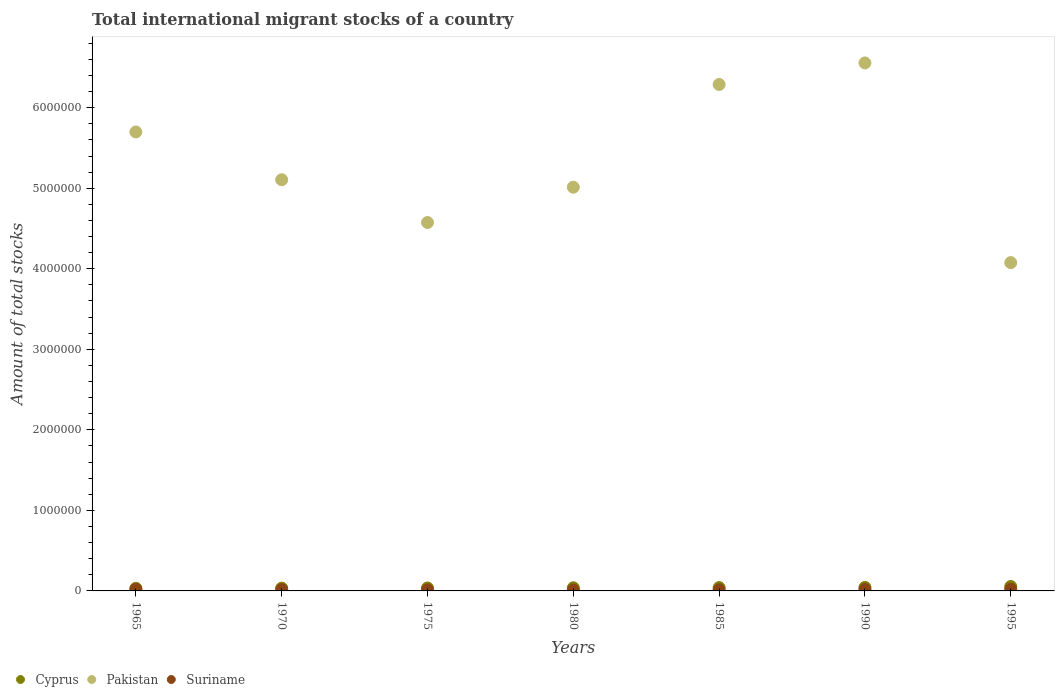How many different coloured dotlines are there?
Your answer should be compact. 3. Is the number of dotlines equal to the number of legend labels?
Your answer should be very brief. Yes. What is the amount of total stocks in in Pakistan in 1980?
Provide a short and direct response. 5.01e+06. Across all years, what is the maximum amount of total stocks in in Pakistan?
Make the answer very short. 6.56e+06. Across all years, what is the minimum amount of total stocks in in Suriname?
Give a very brief answer. 1.18e+04. What is the total amount of total stocks in in Pakistan in the graph?
Provide a short and direct response. 3.73e+07. What is the difference between the amount of total stocks in in Pakistan in 1965 and that in 1985?
Give a very brief answer. -5.90e+05. What is the difference between the amount of total stocks in in Cyprus in 1985 and the amount of total stocks in in Suriname in 1990?
Make the answer very short. 2.32e+04. What is the average amount of total stocks in in Cyprus per year?
Give a very brief answer. 4.04e+04. In the year 1985, what is the difference between the amount of total stocks in in Cyprus and amount of total stocks in in Pakistan?
Your answer should be very brief. -6.25e+06. What is the ratio of the amount of total stocks in in Pakistan in 1980 to that in 1995?
Your answer should be very brief. 1.23. Is the amount of total stocks in in Suriname in 1965 less than that in 1995?
Give a very brief answer. Yes. What is the difference between the highest and the second highest amount of total stocks in in Pakistan?
Provide a short and direct response. 2.68e+05. What is the difference between the highest and the lowest amount of total stocks in in Cyprus?
Make the answer very short. 2.27e+04. Is it the case that in every year, the sum of the amount of total stocks in in Suriname and amount of total stocks in in Cyprus  is greater than the amount of total stocks in in Pakistan?
Offer a terse response. No. Does the amount of total stocks in in Cyprus monotonically increase over the years?
Make the answer very short. Yes. Is the amount of total stocks in in Pakistan strictly greater than the amount of total stocks in in Cyprus over the years?
Your answer should be very brief. Yes. Are the values on the major ticks of Y-axis written in scientific E-notation?
Give a very brief answer. No. Does the graph contain any zero values?
Provide a short and direct response. No. Does the graph contain grids?
Make the answer very short. No. What is the title of the graph?
Ensure brevity in your answer.  Total international migrant stocks of a country. Does "Slovak Republic" appear as one of the legend labels in the graph?
Make the answer very short. No. What is the label or title of the X-axis?
Keep it short and to the point. Years. What is the label or title of the Y-axis?
Make the answer very short. Amount of total stocks. What is the Amount of total stocks in Cyprus in 1965?
Keep it short and to the point. 3.25e+04. What is the Amount of total stocks of Pakistan in 1965?
Your answer should be compact. 5.70e+06. What is the Amount of total stocks of Suriname in 1965?
Provide a short and direct response. 1.91e+04. What is the Amount of total stocks of Cyprus in 1970?
Give a very brief answer. 3.45e+04. What is the Amount of total stocks of Pakistan in 1970?
Your answer should be very brief. 5.11e+06. What is the Amount of total stocks in Suriname in 1970?
Your answer should be compact. 1.63e+04. What is the Amount of total stocks of Cyprus in 1975?
Keep it short and to the point. 3.66e+04. What is the Amount of total stocks in Pakistan in 1975?
Offer a very short reply. 4.57e+06. What is the Amount of total stocks of Suriname in 1975?
Offer a terse response. 1.39e+04. What is the Amount of total stocks of Cyprus in 1980?
Your response must be concise. 3.89e+04. What is the Amount of total stocks of Pakistan in 1980?
Make the answer very short. 5.01e+06. What is the Amount of total stocks in Suriname in 1980?
Your answer should be very brief. 1.18e+04. What is the Amount of total stocks of Cyprus in 1985?
Keep it short and to the point. 4.13e+04. What is the Amount of total stocks of Pakistan in 1985?
Your answer should be compact. 6.29e+06. What is the Amount of total stocks in Suriname in 1985?
Offer a terse response. 1.46e+04. What is the Amount of total stocks in Cyprus in 1990?
Keep it short and to the point. 4.38e+04. What is the Amount of total stocks in Pakistan in 1990?
Ensure brevity in your answer.  6.56e+06. What is the Amount of total stocks of Suriname in 1990?
Ensure brevity in your answer.  1.80e+04. What is the Amount of total stocks of Cyprus in 1995?
Offer a terse response. 5.52e+04. What is the Amount of total stocks in Pakistan in 1995?
Your response must be concise. 4.08e+06. What is the Amount of total stocks in Suriname in 1995?
Make the answer very short. 2.23e+04. Across all years, what is the maximum Amount of total stocks in Cyprus?
Make the answer very short. 5.52e+04. Across all years, what is the maximum Amount of total stocks of Pakistan?
Provide a succinct answer. 6.56e+06. Across all years, what is the maximum Amount of total stocks in Suriname?
Keep it short and to the point. 2.23e+04. Across all years, what is the minimum Amount of total stocks in Cyprus?
Your answer should be very brief. 3.25e+04. Across all years, what is the minimum Amount of total stocks in Pakistan?
Your answer should be compact. 4.08e+06. Across all years, what is the minimum Amount of total stocks of Suriname?
Your answer should be very brief. 1.18e+04. What is the total Amount of total stocks of Cyprus in the graph?
Your response must be concise. 2.83e+05. What is the total Amount of total stocks of Pakistan in the graph?
Offer a terse response. 3.73e+07. What is the total Amount of total stocks of Suriname in the graph?
Give a very brief answer. 1.16e+05. What is the difference between the Amount of total stocks of Cyprus in 1965 and that in 1970?
Your answer should be compact. -2002. What is the difference between the Amount of total stocks in Pakistan in 1965 and that in 1970?
Your answer should be very brief. 5.93e+05. What is the difference between the Amount of total stocks of Suriname in 1965 and that in 1970?
Ensure brevity in your answer.  2838. What is the difference between the Amount of total stocks of Cyprus in 1965 and that in 1975?
Provide a succinct answer. -4127. What is the difference between the Amount of total stocks of Pakistan in 1965 and that in 1975?
Your answer should be compact. 1.12e+06. What is the difference between the Amount of total stocks of Suriname in 1965 and that in 1975?
Make the answer very short. 5254. What is the difference between the Amount of total stocks of Cyprus in 1965 and that in 1980?
Give a very brief answer. -6383. What is the difference between the Amount of total stocks of Pakistan in 1965 and that in 1980?
Your answer should be very brief. 6.86e+05. What is the difference between the Amount of total stocks of Suriname in 1965 and that in 1980?
Make the answer very short. 7312. What is the difference between the Amount of total stocks in Cyprus in 1965 and that in 1985?
Keep it short and to the point. -8779. What is the difference between the Amount of total stocks of Pakistan in 1965 and that in 1985?
Offer a terse response. -5.90e+05. What is the difference between the Amount of total stocks of Suriname in 1965 and that in 1985?
Offer a very short reply. 4534. What is the difference between the Amount of total stocks in Cyprus in 1965 and that in 1990?
Ensure brevity in your answer.  -1.13e+04. What is the difference between the Amount of total stocks of Pakistan in 1965 and that in 1990?
Your answer should be compact. -8.57e+05. What is the difference between the Amount of total stocks of Suriname in 1965 and that in 1990?
Provide a succinct answer. 1101. What is the difference between the Amount of total stocks in Cyprus in 1965 and that in 1995?
Offer a very short reply. -2.27e+04. What is the difference between the Amount of total stocks in Pakistan in 1965 and that in 1995?
Ensure brevity in your answer.  1.62e+06. What is the difference between the Amount of total stocks of Suriname in 1965 and that in 1995?
Give a very brief answer. -3139. What is the difference between the Amount of total stocks of Cyprus in 1970 and that in 1975?
Provide a succinct answer. -2125. What is the difference between the Amount of total stocks in Pakistan in 1970 and that in 1975?
Provide a short and direct response. 5.31e+05. What is the difference between the Amount of total stocks in Suriname in 1970 and that in 1975?
Your answer should be compact. 2416. What is the difference between the Amount of total stocks of Cyprus in 1970 and that in 1980?
Offer a very short reply. -4381. What is the difference between the Amount of total stocks in Pakistan in 1970 and that in 1980?
Give a very brief answer. 9.30e+04. What is the difference between the Amount of total stocks of Suriname in 1970 and that in 1980?
Make the answer very short. 4474. What is the difference between the Amount of total stocks of Cyprus in 1970 and that in 1985?
Keep it short and to the point. -6777. What is the difference between the Amount of total stocks in Pakistan in 1970 and that in 1985?
Offer a very short reply. -1.18e+06. What is the difference between the Amount of total stocks of Suriname in 1970 and that in 1985?
Keep it short and to the point. 1696. What is the difference between the Amount of total stocks of Cyprus in 1970 and that in 1990?
Your response must be concise. -9320. What is the difference between the Amount of total stocks of Pakistan in 1970 and that in 1990?
Your response must be concise. -1.45e+06. What is the difference between the Amount of total stocks in Suriname in 1970 and that in 1990?
Offer a very short reply. -1737. What is the difference between the Amount of total stocks of Cyprus in 1970 and that in 1995?
Offer a very short reply. -2.07e+04. What is the difference between the Amount of total stocks of Pakistan in 1970 and that in 1995?
Your answer should be very brief. 1.03e+06. What is the difference between the Amount of total stocks of Suriname in 1970 and that in 1995?
Ensure brevity in your answer.  -5977. What is the difference between the Amount of total stocks of Cyprus in 1975 and that in 1980?
Provide a succinct answer. -2256. What is the difference between the Amount of total stocks in Pakistan in 1975 and that in 1980?
Make the answer very short. -4.38e+05. What is the difference between the Amount of total stocks of Suriname in 1975 and that in 1980?
Your answer should be very brief. 2058. What is the difference between the Amount of total stocks of Cyprus in 1975 and that in 1985?
Provide a short and direct response. -4652. What is the difference between the Amount of total stocks in Pakistan in 1975 and that in 1985?
Ensure brevity in your answer.  -1.71e+06. What is the difference between the Amount of total stocks in Suriname in 1975 and that in 1985?
Make the answer very short. -720. What is the difference between the Amount of total stocks in Cyprus in 1975 and that in 1990?
Offer a very short reply. -7195. What is the difference between the Amount of total stocks of Pakistan in 1975 and that in 1990?
Offer a very short reply. -1.98e+06. What is the difference between the Amount of total stocks in Suriname in 1975 and that in 1990?
Offer a terse response. -4153. What is the difference between the Amount of total stocks of Cyprus in 1975 and that in 1995?
Keep it short and to the point. -1.86e+04. What is the difference between the Amount of total stocks of Pakistan in 1975 and that in 1995?
Ensure brevity in your answer.  4.98e+05. What is the difference between the Amount of total stocks in Suriname in 1975 and that in 1995?
Offer a very short reply. -8393. What is the difference between the Amount of total stocks in Cyprus in 1980 and that in 1985?
Provide a succinct answer. -2396. What is the difference between the Amount of total stocks of Pakistan in 1980 and that in 1985?
Offer a very short reply. -1.28e+06. What is the difference between the Amount of total stocks of Suriname in 1980 and that in 1985?
Provide a short and direct response. -2778. What is the difference between the Amount of total stocks in Cyprus in 1980 and that in 1990?
Offer a terse response. -4939. What is the difference between the Amount of total stocks of Pakistan in 1980 and that in 1990?
Keep it short and to the point. -1.54e+06. What is the difference between the Amount of total stocks in Suriname in 1980 and that in 1990?
Offer a terse response. -6211. What is the difference between the Amount of total stocks in Cyprus in 1980 and that in 1995?
Offer a terse response. -1.63e+04. What is the difference between the Amount of total stocks of Pakistan in 1980 and that in 1995?
Your answer should be compact. 9.36e+05. What is the difference between the Amount of total stocks in Suriname in 1980 and that in 1995?
Offer a terse response. -1.05e+04. What is the difference between the Amount of total stocks in Cyprus in 1985 and that in 1990?
Make the answer very short. -2543. What is the difference between the Amount of total stocks in Pakistan in 1985 and that in 1990?
Provide a succinct answer. -2.68e+05. What is the difference between the Amount of total stocks in Suriname in 1985 and that in 1990?
Offer a very short reply. -3433. What is the difference between the Amount of total stocks of Cyprus in 1985 and that in 1995?
Keep it short and to the point. -1.39e+04. What is the difference between the Amount of total stocks in Pakistan in 1985 and that in 1995?
Give a very brief answer. 2.21e+06. What is the difference between the Amount of total stocks in Suriname in 1985 and that in 1995?
Make the answer very short. -7673. What is the difference between the Amount of total stocks of Cyprus in 1990 and that in 1995?
Your answer should be very brief. -1.14e+04. What is the difference between the Amount of total stocks in Pakistan in 1990 and that in 1995?
Your response must be concise. 2.48e+06. What is the difference between the Amount of total stocks in Suriname in 1990 and that in 1995?
Provide a short and direct response. -4240. What is the difference between the Amount of total stocks in Cyprus in 1965 and the Amount of total stocks in Pakistan in 1970?
Your answer should be compact. -5.07e+06. What is the difference between the Amount of total stocks in Cyprus in 1965 and the Amount of total stocks in Suriname in 1970?
Your response must be concise. 1.62e+04. What is the difference between the Amount of total stocks in Pakistan in 1965 and the Amount of total stocks in Suriname in 1970?
Offer a very short reply. 5.68e+06. What is the difference between the Amount of total stocks of Cyprus in 1965 and the Amount of total stocks of Pakistan in 1975?
Offer a very short reply. -4.54e+06. What is the difference between the Amount of total stocks in Cyprus in 1965 and the Amount of total stocks in Suriname in 1975?
Make the answer very short. 1.86e+04. What is the difference between the Amount of total stocks of Pakistan in 1965 and the Amount of total stocks of Suriname in 1975?
Give a very brief answer. 5.68e+06. What is the difference between the Amount of total stocks of Cyprus in 1965 and the Amount of total stocks of Pakistan in 1980?
Give a very brief answer. -4.98e+06. What is the difference between the Amount of total stocks of Cyprus in 1965 and the Amount of total stocks of Suriname in 1980?
Make the answer very short. 2.07e+04. What is the difference between the Amount of total stocks of Pakistan in 1965 and the Amount of total stocks of Suriname in 1980?
Give a very brief answer. 5.69e+06. What is the difference between the Amount of total stocks in Cyprus in 1965 and the Amount of total stocks in Pakistan in 1985?
Give a very brief answer. -6.26e+06. What is the difference between the Amount of total stocks in Cyprus in 1965 and the Amount of total stocks in Suriname in 1985?
Your answer should be compact. 1.79e+04. What is the difference between the Amount of total stocks of Pakistan in 1965 and the Amount of total stocks of Suriname in 1985?
Offer a very short reply. 5.68e+06. What is the difference between the Amount of total stocks in Cyprus in 1965 and the Amount of total stocks in Pakistan in 1990?
Keep it short and to the point. -6.52e+06. What is the difference between the Amount of total stocks of Cyprus in 1965 and the Amount of total stocks of Suriname in 1990?
Your answer should be compact. 1.45e+04. What is the difference between the Amount of total stocks of Pakistan in 1965 and the Amount of total stocks of Suriname in 1990?
Offer a terse response. 5.68e+06. What is the difference between the Amount of total stocks of Cyprus in 1965 and the Amount of total stocks of Pakistan in 1995?
Provide a succinct answer. -4.04e+06. What is the difference between the Amount of total stocks of Cyprus in 1965 and the Amount of total stocks of Suriname in 1995?
Offer a terse response. 1.02e+04. What is the difference between the Amount of total stocks of Pakistan in 1965 and the Amount of total stocks of Suriname in 1995?
Provide a short and direct response. 5.68e+06. What is the difference between the Amount of total stocks of Cyprus in 1970 and the Amount of total stocks of Pakistan in 1975?
Offer a terse response. -4.54e+06. What is the difference between the Amount of total stocks in Cyprus in 1970 and the Amount of total stocks in Suriname in 1975?
Make the answer very short. 2.06e+04. What is the difference between the Amount of total stocks of Pakistan in 1970 and the Amount of total stocks of Suriname in 1975?
Provide a short and direct response. 5.09e+06. What is the difference between the Amount of total stocks in Cyprus in 1970 and the Amount of total stocks in Pakistan in 1980?
Give a very brief answer. -4.98e+06. What is the difference between the Amount of total stocks in Cyprus in 1970 and the Amount of total stocks in Suriname in 1980?
Provide a short and direct response. 2.27e+04. What is the difference between the Amount of total stocks in Pakistan in 1970 and the Amount of total stocks in Suriname in 1980?
Your answer should be compact. 5.09e+06. What is the difference between the Amount of total stocks of Cyprus in 1970 and the Amount of total stocks of Pakistan in 1985?
Make the answer very short. -6.25e+06. What is the difference between the Amount of total stocks of Cyprus in 1970 and the Amount of total stocks of Suriname in 1985?
Provide a short and direct response. 1.99e+04. What is the difference between the Amount of total stocks in Pakistan in 1970 and the Amount of total stocks in Suriname in 1985?
Your response must be concise. 5.09e+06. What is the difference between the Amount of total stocks of Cyprus in 1970 and the Amount of total stocks of Pakistan in 1990?
Your answer should be very brief. -6.52e+06. What is the difference between the Amount of total stocks of Cyprus in 1970 and the Amount of total stocks of Suriname in 1990?
Ensure brevity in your answer.  1.65e+04. What is the difference between the Amount of total stocks of Pakistan in 1970 and the Amount of total stocks of Suriname in 1990?
Your answer should be compact. 5.09e+06. What is the difference between the Amount of total stocks in Cyprus in 1970 and the Amount of total stocks in Pakistan in 1995?
Provide a short and direct response. -4.04e+06. What is the difference between the Amount of total stocks in Cyprus in 1970 and the Amount of total stocks in Suriname in 1995?
Keep it short and to the point. 1.22e+04. What is the difference between the Amount of total stocks in Pakistan in 1970 and the Amount of total stocks in Suriname in 1995?
Ensure brevity in your answer.  5.08e+06. What is the difference between the Amount of total stocks of Cyprus in 1975 and the Amount of total stocks of Pakistan in 1980?
Offer a terse response. -4.98e+06. What is the difference between the Amount of total stocks of Cyprus in 1975 and the Amount of total stocks of Suriname in 1980?
Ensure brevity in your answer.  2.48e+04. What is the difference between the Amount of total stocks of Pakistan in 1975 and the Amount of total stocks of Suriname in 1980?
Provide a short and direct response. 4.56e+06. What is the difference between the Amount of total stocks in Cyprus in 1975 and the Amount of total stocks in Pakistan in 1985?
Your response must be concise. -6.25e+06. What is the difference between the Amount of total stocks of Cyprus in 1975 and the Amount of total stocks of Suriname in 1985?
Provide a succinct answer. 2.20e+04. What is the difference between the Amount of total stocks of Pakistan in 1975 and the Amount of total stocks of Suriname in 1985?
Your answer should be very brief. 4.56e+06. What is the difference between the Amount of total stocks in Cyprus in 1975 and the Amount of total stocks in Pakistan in 1990?
Your response must be concise. -6.52e+06. What is the difference between the Amount of total stocks in Cyprus in 1975 and the Amount of total stocks in Suriname in 1990?
Your answer should be compact. 1.86e+04. What is the difference between the Amount of total stocks in Pakistan in 1975 and the Amount of total stocks in Suriname in 1990?
Your response must be concise. 4.56e+06. What is the difference between the Amount of total stocks in Cyprus in 1975 and the Amount of total stocks in Pakistan in 1995?
Offer a very short reply. -4.04e+06. What is the difference between the Amount of total stocks of Cyprus in 1975 and the Amount of total stocks of Suriname in 1995?
Provide a succinct answer. 1.43e+04. What is the difference between the Amount of total stocks of Pakistan in 1975 and the Amount of total stocks of Suriname in 1995?
Provide a succinct answer. 4.55e+06. What is the difference between the Amount of total stocks in Cyprus in 1980 and the Amount of total stocks in Pakistan in 1985?
Provide a short and direct response. -6.25e+06. What is the difference between the Amount of total stocks of Cyprus in 1980 and the Amount of total stocks of Suriname in 1985?
Give a very brief answer. 2.43e+04. What is the difference between the Amount of total stocks of Pakistan in 1980 and the Amount of total stocks of Suriname in 1985?
Provide a short and direct response. 5.00e+06. What is the difference between the Amount of total stocks in Cyprus in 1980 and the Amount of total stocks in Pakistan in 1990?
Offer a very short reply. -6.52e+06. What is the difference between the Amount of total stocks in Cyprus in 1980 and the Amount of total stocks in Suriname in 1990?
Keep it short and to the point. 2.08e+04. What is the difference between the Amount of total stocks in Pakistan in 1980 and the Amount of total stocks in Suriname in 1990?
Your answer should be very brief. 4.99e+06. What is the difference between the Amount of total stocks in Cyprus in 1980 and the Amount of total stocks in Pakistan in 1995?
Keep it short and to the point. -4.04e+06. What is the difference between the Amount of total stocks of Cyprus in 1980 and the Amount of total stocks of Suriname in 1995?
Make the answer very short. 1.66e+04. What is the difference between the Amount of total stocks of Pakistan in 1980 and the Amount of total stocks of Suriname in 1995?
Provide a succinct answer. 4.99e+06. What is the difference between the Amount of total stocks of Cyprus in 1985 and the Amount of total stocks of Pakistan in 1990?
Provide a short and direct response. -6.51e+06. What is the difference between the Amount of total stocks in Cyprus in 1985 and the Amount of total stocks in Suriname in 1990?
Your answer should be compact. 2.32e+04. What is the difference between the Amount of total stocks of Pakistan in 1985 and the Amount of total stocks of Suriname in 1990?
Your response must be concise. 6.27e+06. What is the difference between the Amount of total stocks in Cyprus in 1985 and the Amount of total stocks in Pakistan in 1995?
Provide a short and direct response. -4.04e+06. What is the difference between the Amount of total stocks of Cyprus in 1985 and the Amount of total stocks of Suriname in 1995?
Offer a terse response. 1.90e+04. What is the difference between the Amount of total stocks in Pakistan in 1985 and the Amount of total stocks in Suriname in 1995?
Ensure brevity in your answer.  6.27e+06. What is the difference between the Amount of total stocks of Cyprus in 1990 and the Amount of total stocks of Pakistan in 1995?
Your response must be concise. -4.03e+06. What is the difference between the Amount of total stocks of Cyprus in 1990 and the Amount of total stocks of Suriname in 1995?
Your answer should be very brief. 2.15e+04. What is the difference between the Amount of total stocks in Pakistan in 1990 and the Amount of total stocks in Suriname in 1995?
Offer a very short reply. 6.53e+06. What is the average Amount of total stocks of Cyprus per year?
Offer a very short reply. 4.04e+04. What is the average Amount of total stocks of Pakistan per year?
Your answer should be very brief. 5.33e+06. What is the average Amount of total stocks in Suriname per year?
Make the answer very short. 1.66e+04. In the year 1965, what is the difference between the Amount of total stocks of Cyprus and Amount of total stocks of Pakistan?
Make the answer very short. -5.67e+06. In the year 1965, what is the difference between the Amount of total stocks of Cyprus and Amount of total stocks of Suriname?
Provide a succinct answer. 1.34e+04. In the year 1965, what is the difference between the Amount of total stocks of Pakistan and Amount of total stocks of Suriname?
Keep it short and to the point. 5.68e+06. In the year 1970, what is the difference between the Amount of total stocks of Cyprus and Amount of total stocks of Pakistan?
Your answer should be compact. -5.07e+06. In the year 1970, what is the difference between the Amount of total stocks in Cyprus and Amount of total stocks in Suriname?
Ensure brevity in your answer.  1.82e+04. In the year 1970, what is the difference between the Amount of total stocks in Pakistan and Amount of total stocks in Suriname?
Provide a short and direct response. 5.09e+06. In the year 1975, what is the difference between the Amount of total stocks of Cyprus and Amount of total stocks of Pakistan?
Ensure brevity in your answer.  -4.54e+06. In the year 1975, what is the difference between the Amount of total stocks of Cyprus and Amount of total stocks of Suriname?
Provide a short and direct response. 2.27e+04. In the year 1975, what is the difference between the Amount of total stocks of Pakistan and Amount of total stocks of Suriname?
Provide a succinct answer. 4.56e+06. In the year 1980, what is the difference between the Amount of total stocks of Cyprus and Amount of total stocks of Pakistan?
Make the answer very short. -4.97e+06. In the year 1980, what is the difference between the Amount of total stocks of Cyprus and Amount of total stocks of Suriname?
Ensure brevity in your answer.  2.70e+04. In the year 1980, what is the difference between the Amount of total stocks of Pakistan and Amount of total stocks of Suriname?
Your answer should be compact. 5.00e+06. In the year 1985, what is the difference between the Amount of total stocks of Cyprus and Amount of total stocks of Pakistan?
Your answer should be compact. -6.25e+06. In the year 1985, what is the difference between the Amount of total stocks of Cyprus and Amount of total stocks of Suriname?
Your response must be concise. 2.67e+04. In the year 1985, what is the difference between the Amount of total stocks in Pakistan and Amount of total stocks in Suriname?
Keep it short and to the point. 6.27e+06. In the year 1990, what is the difference between the Amount of total stocks in Cyprus and Amount of total stocks in Pakistan?
Give a very brief answer. -6.51e+06. In the year 1990, what is the difference between the Amount of total stocks in Cyprus and Amount of total stocks in Suriname?
Give a very brief answer. 2.58e+04. In the year 1990, what is the difference between the Amount of total stocks in Pakistan and Amount of total stocks in Suriname?
Offer a terse response. 6.54e+06. In the year 1995, what is the difference between the Amount of total stocks of Cyprus and Amount of total stocks of Pakistan?
Provide a short and direct response. -4.02e+06. In the year 1995, what is the difference between the Amount of total stocks of Cyprus and Amount of total stocks of Suriname?
Your answer should be compact. 3.29e+04. In the year 1995, what is the difference between the Amount of total stocks in Pakistan and Amount of total stocks in Suriname?
Provide a succinct answer. 4.05e+06. What is the ratio of the Amount of total stocks of Cyprus in 1965 to that in 1970?
Your answer should be compact. 0.94. What is the ratio of the Amount of total stocks of Pakistan in 1965 to that in 1970?
Provide a short and direct response. 1.12. What is the ratio of the Amount of total stocks in Suriname in 1965 to that in 1970?
Offer a terse response. 1.17. What is the ratio of the Amount of total stocks of Cyprus in 1965 to that in 1975?
Ensure brevity in your answer.  0.89. What is the ratio of the Amount of total stocks of Pakistan in 1965 to that in 1975?
Your response must be concise. 1.25. What is the ratio of the Amount of total stocks in Suriname in 1965 to that in 1975?
Provide a short and direct response. 1.38. What is the ratio of the Amount of total stocks of Cyprus in 1965 to that in 1980?
Your response must be concise. 0.84. What is the ratio of the Amount of total stocks in Pakistan in 1965 to that in 1980?
Keep it short and to the point. 1.14. What is the ratio of the Amount of total stocks in Suriname in 1965 to that in 1980?
Provide a succinct answer. 1.62. What is the ratio of the Amount of total stocks of Cyprus in 1965 to that in 1985?
Provide a succinct answer. 0.79. What is the ratio of the Amount of total stocks in Pakistan in 1965 to that in 1985?
Give a very brief answer. 0.91. What is the ratio of the Amount of total stocks of Suriname in 1965 to that in 1985?
Make the answer very short. 1.31. What is the ratio of the Amount of total stocks in Cyprus in 1965 to that in 1990?
Ensure brevity in your answer.  0.74. What is the ratio of the Amount of total stocks in Pakistan in 1965 to that in 1990?
Keep it short and to the point. 0.87. What is the ratio of the Amount of total stocks of Suriname in 1965 to that in 1990?
Provide a short and direct response. 1.06. What is the ratio of the Amount of total stocks of Cyprus in 1965 to that in 1995?
Provide a short and direct response. 0.59. What is the ratio of the Amount of total stocks in Pakistan in 1965 to that in 1995?
Keep it short and to the point. 1.4. What is the ratio of the Amount of total stocks of Suriname in 1965 to that in 1995?
Offer a terse response. 0.86. What is the ratio of the Amount of total stocks of Cyprus in 1970 to that in 1975?
Provide a succinct answer. 0.94. What is the ratio of the Amount of total stocks of Pakistan in 1970 to that in 1975?
Keep it short and to the point. 1.12. What is the ratio of the Amount of total stocks in Suriname in 1970 to that in 1975?
Your response must be concise. 1.17. What is the ratio of the Amount of total stocks of Cyprus in 1970 to that in 1980?
Provide a succinct answer. 0.89. What is the ratio of the Amount of total stocks in Pakistan in 1970 to that in 1980?
Your response must be concise. 1.02. What is the ratio of the Amount of total stocks in Suriname in 1970 to that in 1980?
Ensure brevity in your answer.  1.38. What is the ratio of the Amount of total stocks of Cyprus in 1970 to that in 1985?
Make the answer very short. 0.84. What is the ratio of the Amount of total stocks in Pakistan in 1970 to that in 1985?
Provide a succinct answer. 0.81. What is the ratio of the Amount of total stocks of Suriname in 1970 to that in 1985?
Give a very brief answer. 1.12. What is the ratio of the Amount of total stocks of Cyprus in 1970 to that in 1990?
Offer a terse response. 0.79. What is the ratio of the Amount of total stocks in Pakistan in 1970 to that in 1990?
Ensure brevity in your answer.  0.78. What is the ratio of the Amount of total stocks of Suriname in 1970 to that in 1990?
Your answer should be very brief. 0.9. What is the ratio of the Amount of total stocks of Cyprus in 1970 to that in 1995?
Provide a succinct answer. 0.62. What is the ratio of the Amount of total stocks in Pakistan in 1970 to that in 1995?
Offer a terse response. 1.25. What is the ratio of the Amount of total stocks of Suriname in 1970 to that in 1995?
Offer a very short reply. 0.73. What is the ratio of the Amount of total stocks in Cyprus in 1975 to that in 1980?
Provide a short and direct response. 0.94. What is the ratio of the Amount of total stocks of Pakistan in 1975 to that in 1980?
Make the answer very short. 0.91. What is the ratio of the Amount of total stocks of Suriname in 1975 to that in 1980?
Make the answer very short. 1.17. What is the ratio of the Amount of total stocks in Cyprus in 1975 to that in 1985?
Provide a succinct answer. 0.89. What is the ratio of the Amount of total stocks of Pakistan in 1975 to that in 1985?
Provide a short and direct response. 0.73. What is the ratio of the Amount of total stocks of Suriname in 1975 to that in 1985?
Provide a succinct answer. 0.95. What is the ratio of the Amount of total stocks in Cyprus in 1975 to that in 1990?
Make the answer very short. 0.84. What is the ratio of the Amount of total stocks of Pakistan in 1975 to that in 1990?
Provide a succinct answer. 0.7. What is the ratio of the Amount of total stocks of Suriname in 1975 to that in 1990?
Your response must be concise. 0.77. What is the ratio of the Amount of total stocks in Cyprus in 1975 to that in 1995?
Your answer should be compact. 0.66. What is the ratio of the Amount of total stocks of Pakistan in 1975 to that in 1995?
Offer a very short reply. 1.12. What is the ratio of the Amount of total stocks of Suriname in 1975 to that in 1995?
Keep it short and to the point. 0.62. What is the ratio of the Amount of total stocks of Cyprus in 1980 to that in 1985?
Offer a terse response. 0.94. What is the ratio of the Amount of total stocks of Pakistan in 1980 to that in 1985?
Your answer should be very brief. 0.8. What is the ratio of the Amount of total stocks of Suriname in 1980 to that in 1985?
Make the answer very short. 0.81. What is the ratio of the Amount of total stocks of Cyprus in 1980 to that in 1990?
Offer a terse response. 0.89. What is the ratio of the Amount of total stocks in Pakistan in 1980 to that in 1990?
Provide a short and direct response. 0.76. What is the ratio of the Amount of total stocks of Suriname in 1980 to that in 1990?
Provide a succinct answer. 0.66. What is the ratio of the Amount of total stocks in Cyprus in 1980 to that in 1995?
Offer a terse response. 0.7. What is the ratio of the Amount of total stocks in Pakistan in 1980 to that in 1995?
Offer a terse response. 1.23. What is the ratio of the Amount of total stocks in Suriname in 1980 to that in 1995?
Make the answer very short. 0.53. What is the ratio of the Amount of total stocks of Cyprus in 1985 to that in 1990?
Your answer should be compact. 0.94. What is the ratio of the Amount of total stocks in Pakistan in 1985 to that in 1990?
Offer a terse response. 0.96. What is the ratio of the Amount of total stocks of Suriname in 1985 to that in 1990?
Offer a very short reply. 0.81. What is the ratio of the Amount of total stocks of Cyprus in 1985 to that in 1995?
Your answer should be very brief. 0.75. What is the ratio of the Amount of total stocks of Pakistan in 1985 to that in 1995?
Provide a succinct answer. 1.54. What is the ratio of the Amount of total stocks of Suriname in 1985 to that in 1995?
Your response must be concise. 0.66. What is the ratio of the Amount of total stocks in Cyprus in 1990 to that in 1995?
Provide a short and direct response. 0.79. What is the ratio of the Amount of total stocks in Pakistan in 1990 to that in 1995?
Ensure brevity in your answer.  1.61. What is the ratio of the Amount of total stocks of Suriname in 1990 to that in 1995?
Provide a short and direct response. 0.81. What is the difference between the highest and the second highest Amount of total stocks in Cyprus?
Offer a terse response. 1.14e+04. What is the difference between the highest and the second highest Amount of total stocks in Pakistan?
Your answer should be very brief. 2.68e+05. What is the difference between the highest and the second highest Amount of total stocks of Suriname?
Make the answer very short. 3139. What is the difference between the highest and the lowest Amount of total stocks of Cyprus?
Ensure brevity in your answer.  2.27e+04. What is the difference between the highest and the lowest Amount of total stocks in Pakistan?
Keep it short and to the point. 2.48e+06. What is the difference between the highest and the lowest Amount of total stocks in Suriname?
Provide a short and direct response. 1.05e+04. 